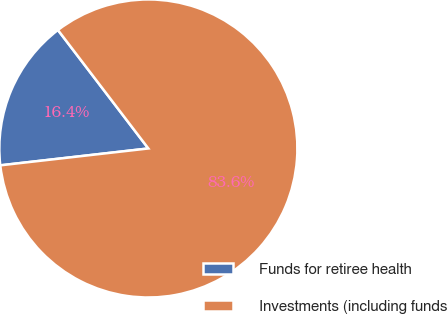Convert chart. <chart><loc_0><loc_0><loc_500><loc_500><pie_chart><fcel>Funds for retiree health<fcel>Investments (including funds<nl><fcel>16.43%<fcel>83.57%<nl></chart> 